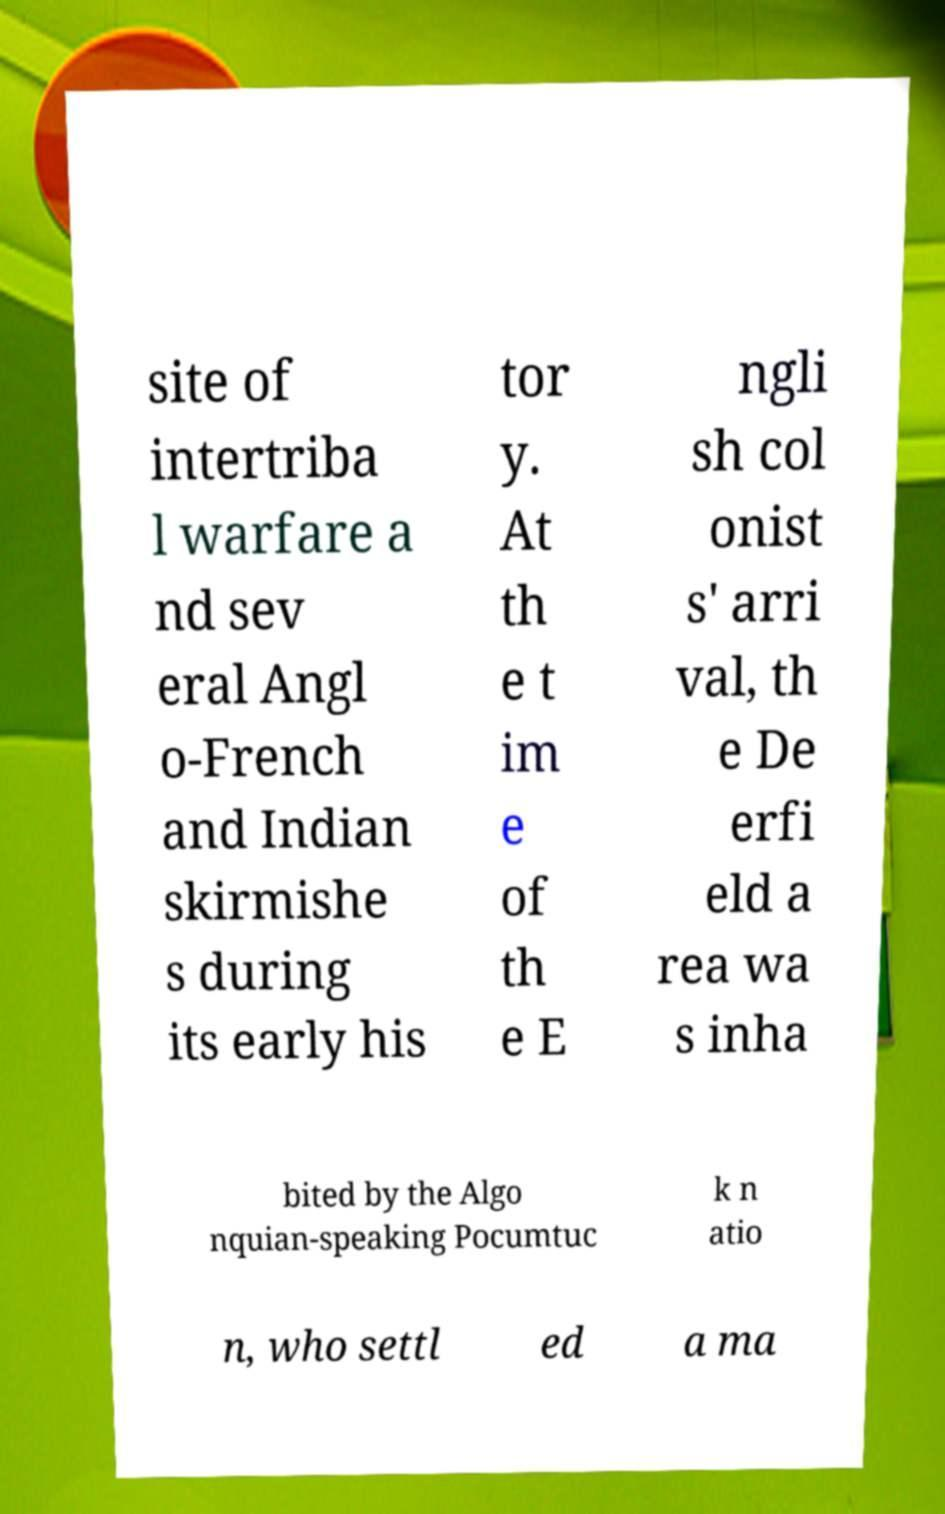What messages or text are displayed in this image? I need them in a readable, typed format. site of intertriba l warfare a nd sev eral Angl o-French and Indian skirmishe s during its early his tor y. At th e t im e of th e E ngli sh col onist s' arri val, th e De erfi eld a rea wa s inha bited by the Algo nquian-speaking Pocumtuc k n atio n, who settl ed a ma 